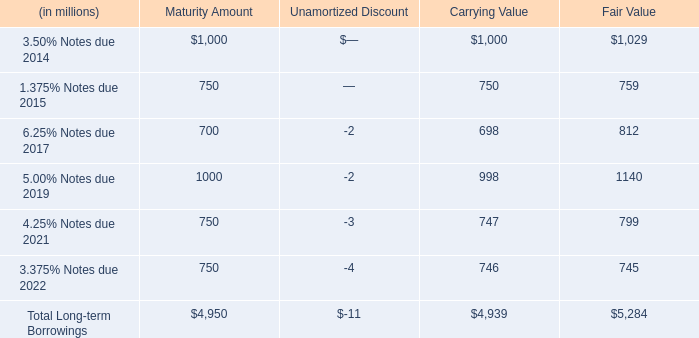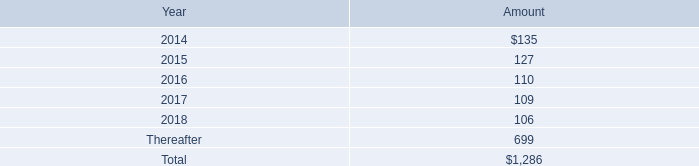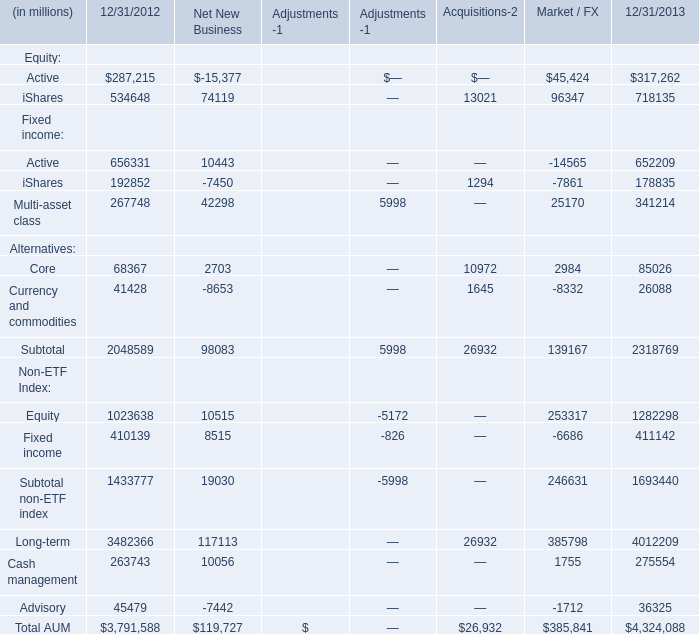what is the growth rate in rent expense and certain office equipment expense in 2013 compare to 2012? 
Computations: ((137 - 133) / 133)
Answer: 0.03008. 